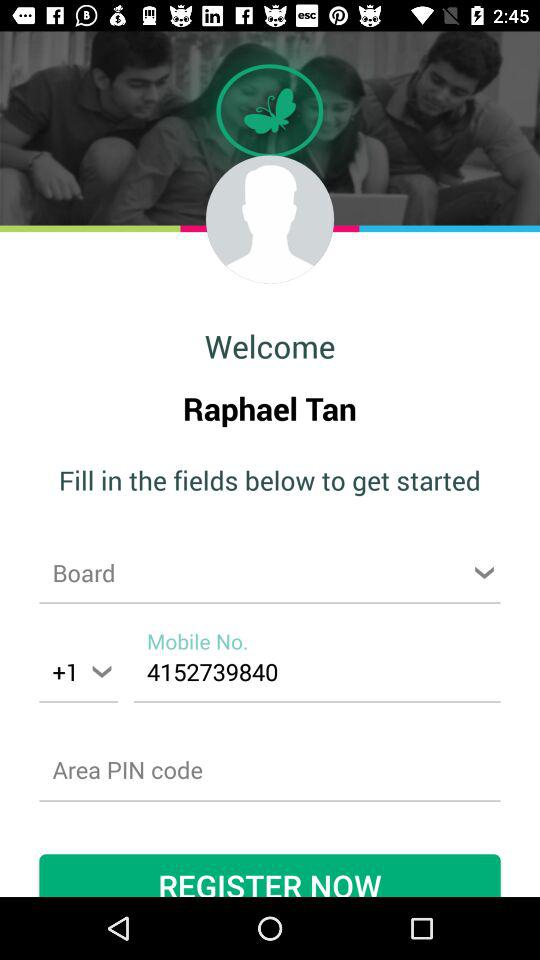What is the given country code? The given country code is +1. 